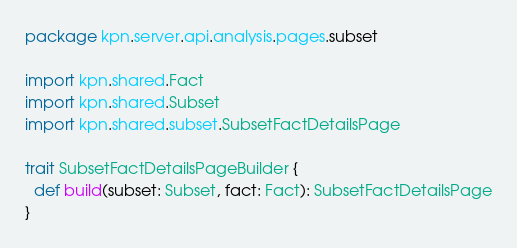Convert code to text. <code><loc_0><loc_0><loc_500><loc_500><_Scala_>package kpn.server.api.analysis.pages.subset

import kpn.shared.Fact
import kpn.shared.Subset
import kpn.shared.subset.SubsetFactDetailsPage

trait SubsetFactDetailsPageBuilder {
  def build(subset: Subset, fact: Fact): SubsetFactDetailsPage
}
</code> 